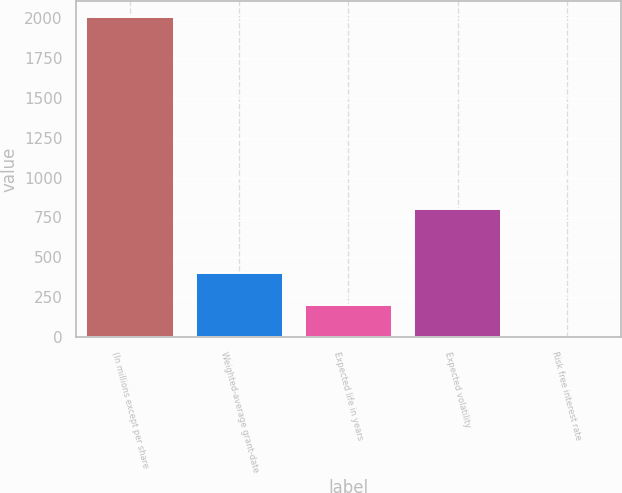Convert chart to OTSL. <chart><loc_0><loc_0><loc_500><loc_500><bar_chart><fcel>(In millions except per share<fcel>Weighted-average grant-date<fcel>Expected life in years<fcel>Expected volatility<fcel>Risk free interest rate<nl><fcel>2003<fcel>403<fcel>203<fcel>803<fcel>3<nl></chart> 